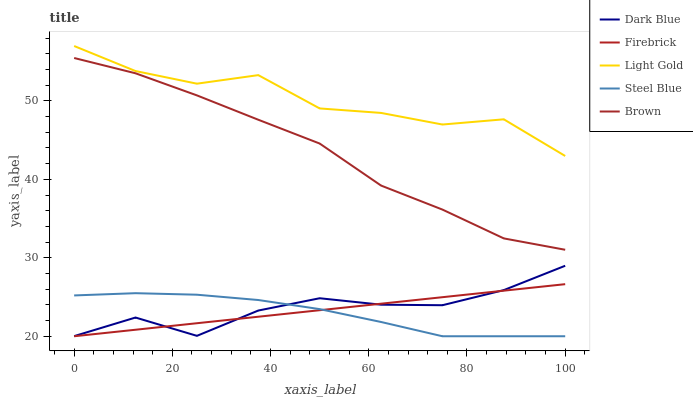Does Firebrick have the minimum area under the curve?
Answer yes or no. No. Does Firebrick have the maximum area under the curve?
Answer yes or no. No. Is Light Gold the smoothest?
Answer yes or no. No. Is Firebrick the roughest?
Answer yes or no. No. Does Light Gold have the lowest value?
Answer yes or no. No. Does Firebrick have the highest value?
Answer yes or no. No. Is Firebrick less than Light Gold?
Answer yes or no. Yes. Is Light Gold greater than Dark Blue?
Answer yes or no. Yes. Does Firebrick intersect Light Gold?
Answer yes or no. No. 